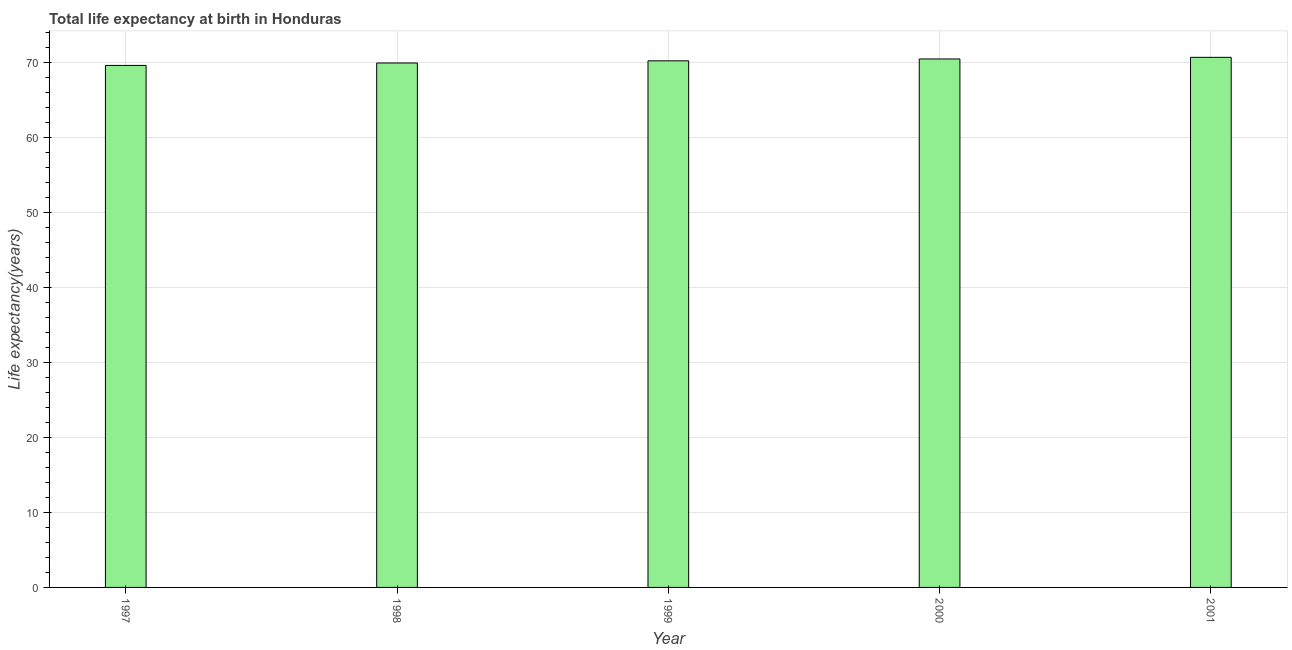Does the graph contain any zero values?
Offer a very short reply. No. Does the graph contain grids?
Give a very brief answer. Yes. What is the title of the graph?
Your response must be concise. Total life expectancy at birth in Honduras. What is the label or title of the X-axis?
Offer a terse response. Year. What is the label or title of the Y-axis?
Your answer should be very brief. Life expectancy(years). What is the life expectancy at birth in 1999?
Your answer should be very brief. 70.25. Across all years, what is the maximum life expectancy at birth?
Your response must be concise. 70.71. Across all years, what is the minimum life expectancy at birth?
Your answer should be very brief. 69.63. In which year was the life expectancy at birth maximum?
Keep it short and to the point. 2001. What is the sum of the life expectancy at birth?
Your response must be concise. 351.04. What is the difference between the life expectancy at birth in 2000 and 2001?
Provide a short and direct response. -0.22. What is the average life expectancy at birth per year?
Ensure brevity in your answer.  70.21. What is the median life expectancy at birth?
Your answer should be very brief. 70.25. In how many years, is the life expectancy at birth greater than 64 years?
Provide a succinct answer. 5. Do a majority of the years between 1998 and 2001 (inclusive) have life expectancy at birth greater than 2 years?
Ensure brevity in your answer.  Yes. Is the life expectancy at birth in 1999 less than that in 2000?
Your answer should be compact. Yes. What is the difference between the highest and the second highest life expectancy at birth?
Make the answer very short. 0.22. Is the sum of the life expectancy at birth in 1997 and 1998 greater than the maximum life expectancy at birth across all years?
Your answer should be very brief. Yes. Are all the bars in the graph horizontal?
Provide a short and direct response. No. What is the difference between two consecutive major ticks on the Y-axis?
Give a very brief answer. 10. What is the Life expectancy(years) of 1997?
Give a very brief answer. 69.63. What is the Life expectancy(years) of 1998?
Offer a terse response. 69.96. What is the Life expectancy(years) in 1999?
Provide a short and direct response. 70.25. What is the Life expectancy(years) in 2000?
Make the answer very short. 70.49. What is the Life expectancy(years) in 2001?
Your answer should be very brief. 70.71. What is the difference between the Life expectancy(years) in 1997 and 1998?
Provide a succinct answer. -0.33. What is the difference between the Life expectancy(years) in 1997 and 1999?
Offer a very short reply. -0.62. What is the difference between the Life expectancy(years) in 1997 and 2000?
Make the answer very short. -0.86. What is the difference between the Life expectancy(years) in 1997 and 2001?
Offer a terse response. -1.08. What is the difference between the Life expectancy(years) in 1998 and 1999?
Provide a succinct answer. -0.29. What is the difference between the Life expectancy(years) in 1998 and 2000?
Your answer should be compact. -0.54. What is the difference between the Life expectancy(years) in 1998 and 2001?
Ensure brevity in your answer.  -0.75. What is the difference between the Life expectancy(years) in 1999 and 2000?
Your answer should be very brief. -0.25. What is the difference between the Life expectancy(years) in 1999 and 2001?
Offer a terse response. -0.47. What is the difference between the Life expectancy(years) in 2000 and 2001?
Your answer should be compact. -0.22. What is the ratio of the Life expectancy(years) in 1997 to that in 1999?
Your answer should be compact. 0.99. What is the ratio of the Life expectancy(years) in 1997 to that in 2000?
Give a very brief answer. 0.99. What is the ratio of the Life expectancy(years) in 1998 to that in 1999?
Offer a terse response. 1. What is the ratio of the Life expectancy(years) in 1998 to that in 2000?
Give a very brief answer. 0.99. What is the ratio of the Life expectancy(years) in 1999 to that in 2000?
Keep it short and to the point. 1. 